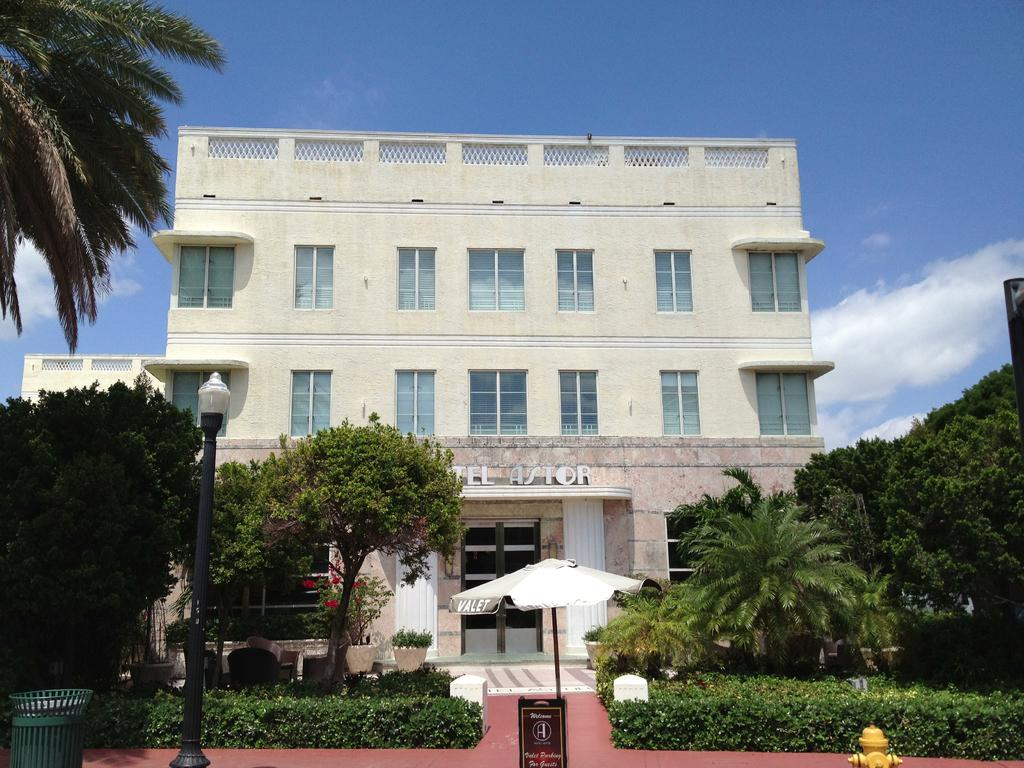<image>
Provide a brief description of the given image. The facade and outside of a hotel called Astor. 